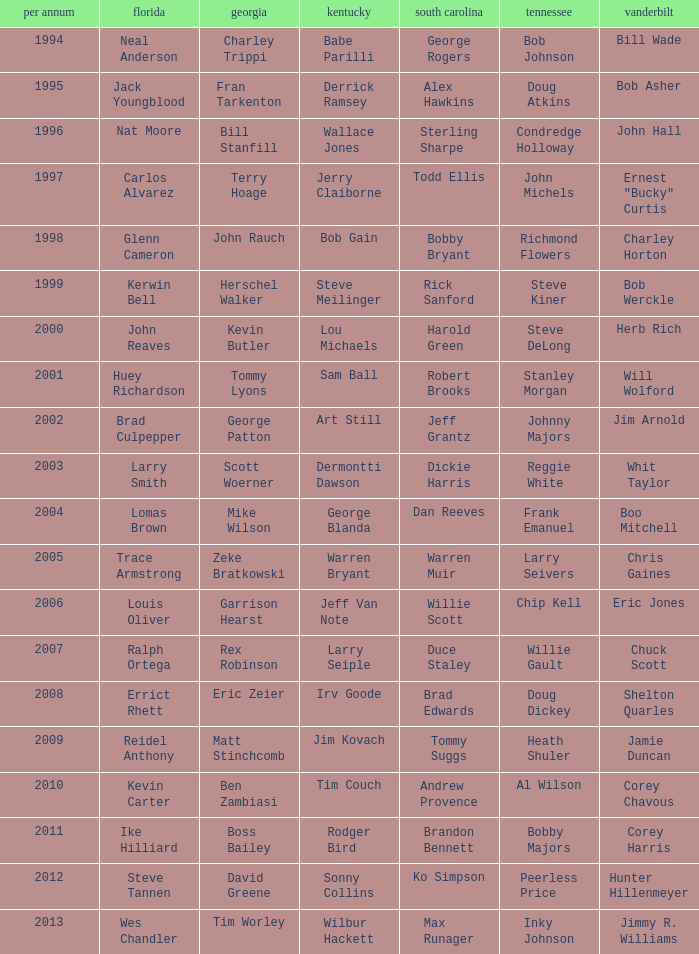What is the total Year of jeff van note ( Kentucky) 2006.0. 